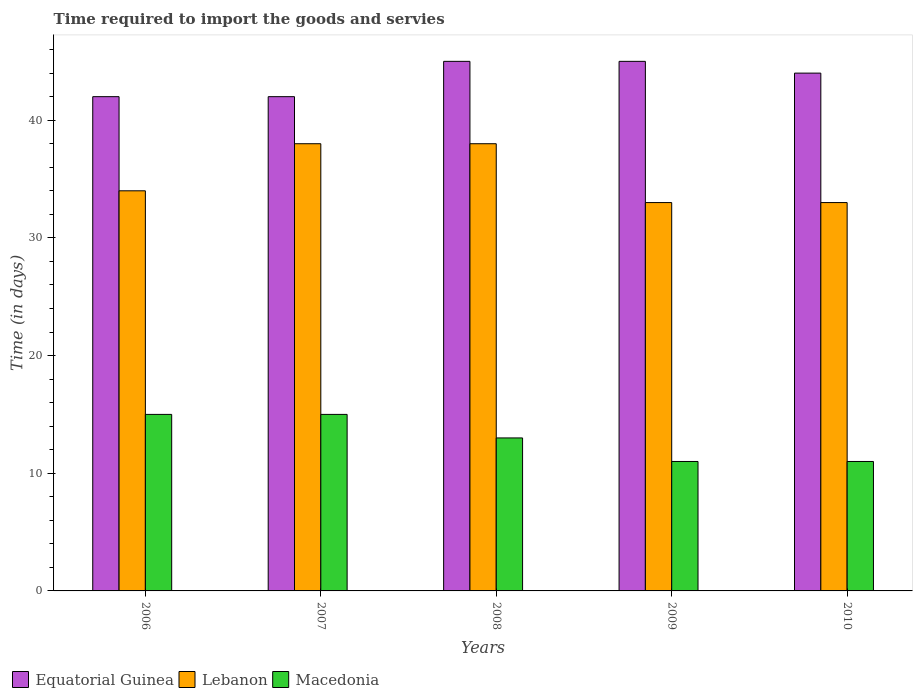How many different coloured bars are there?
Keep it short and to the point. 3. How many bars are there on the 4th tick from the left?
Offer a very short reply. 3. How many bars are there on the 5th tick from the right?
Provide a short and direct response. 3. What is the label of the 5th group of bars from the left?
Your response must be concise. 2010. What is the number of days required to import the goods and services in Lebanon in 2009?
Your answer should be very brief. 33. Across all years, what is the maximum number of days required to import the goods and services in Macedonia?
Provide a short and direct response. 15. Across all years, what is the minimum number of days required to import the goods and services in Equatorial Guinea?
Give a very brief answer. 42. In which year was the number of days required to import the goods and services in Macedonia maximum?
Provide a succinct answer. 2006. In which year was the number of days required to import the goods and services in Macedonia minimum?
Provide a short and direct response. 2009. What is the total number of days required to import the goods and services in Macedonia in the graph?
Offer a very short reply. 65. What is the difference between the number of days required to import the goods and services in Lebanon in 2007 and that in 2009?
Your response must be concise. 5. What is the difference between the number of days required to import the goods and services in Macedonia in 2010 and the number of days required to import the goods and services in Lebanon in 2006?
Ensure brevity in your answer.  -23. In the year 2009, what is the difference between the number of days required to import the goods and services in Lebanon and number of days required to import the goods and services in Macedonia?
Make the answer very short. 22. In how many years, is the number of days required to import the goods and services in Equatorial Guinea greater than 20 days?
Your response must be concise. 5. What is the ratio of the number of days required to import the goods and services in Equatorial Guinea in 2007 to that in 2008?
Give a very brief answer. 0.93. What is the difference between the highest and the second highest number of days required to import the goods and services in Equatorial Guinea?
Your answer should be compact. 0. What is the difference between the highest and the lowest number of days required to import the goods and services in Equatorial Guinea?
Your answer should be very brief. 3. In how many years, is the number of days required to import the goods and services in Macedonia greater than the average number of days required to import the goods and services in Macedonia taken over all years?
Provide a succinct answer. 2. What does the 3rd bar from the left in 2010 represents?
Offer a very short reply. Macedonia. What does the 1st bar from the right in 2009 represents?
Offer a very short reply. Macedonia. Is it the case that in every year, the sum of the number of days required to import the goods and services in Lebanon and number of days required to import the goods and services in Equatorial Guinea is greater than the number of days required to import the goods and services in Macedonia?
Your answer should be compact. Yes. Are all the bars in the graph horizontal?
Give a very brief answer. No. How many years are there in the graph?
Offer a very short reply. 5. Are the values on the major ticks of Y-axis written in scientific E-notation?
Offer a terse response. No. Does the graph contain grids?
Give a very brief answer. No. How many legend labels are there?
Provide a succinct answer. 3. How are the legend labels stacked?
Your answer should be very brief. Horizontal. What is the title of the graph?
Give a very brief answer. Time required to import the goods and servies. Does "Qatar" appear as one of the legend labels in the graph?
Offer a very short reply. No. What is the label or title of the X-axis?
Your answer should be very brief. Years. What is the label or title of the Y-axis?
Ensure brevity in your answer.  Time (in days). What is the Time (in days) in Macedonia in 2006?
Your answer should be compact. 15. What is the Time (in days) in Lebanon in 2007?
Offer a terse response. 38. What is the Time (in days) in Macedonia in 2007?
Provide a short and direct response. 15. What is the Time (in days) in Equatorial Guinea in 2008?
Ensure brevity in your answer.  45. What is the Time (in days) of Lebanon in 2008?
Provide a succinct answer. 38. What is the Time (in days) in Lebanon in 2009?
Make the answer very short. 33. What is the Time (in days) in Macedonia in 2009?
Give a very brief answer. 11. What is the Time (in days) in Lebanon in 2010?
Give a very brief answer. 33. What is the Time (in days) in Macedonia in 2010?
Offer a very short reply. 11. Across all years, what is the maximum Time (in days) in Lebanon?
Provide a succinct answer. 38. Across all years, what is the maximum Time (in days) of Macedonia?
Ensure brevity in your answer.  15. Across all years, what is the minimum Time (in days) in Macedonia?
Your answer should be very brief. 11. What is the total Time (in days) in Equatorial Guinea in the graph?
Your response must be concise. 218. What is the total Time (in days) of Lebanon in the graph?
Offer a very short reply. 176. What is the difference between the Time (in days) of Lebanon in 2006 and that in 2007?
Offer a very short reply. -4. What is the difference between the Time (in days) in Macedonia in 2006 and that in 2007?
Make the answer very short. 0. What is the difference between the Time (in days) in Equatorial Guinea in 2006 and that in 2008?
Offer a very short reply. -3. What is the difference between the Time (in days) in Lebanon in 2006 and that in 2008?
Offer a very short reply. -4. What is the difference between the Time (in days) of Macedonia in 2006 and that in 2008?
Offer a very short reply. 2. What is the difference between the Time (in days) of Equatorial Guinea in 2006 and that in 2009?
Make the answer very short. -3. What is the difference between the Time (in days) of Macedonia in 2006 and that in 2009?
Offer a very short reply. 4. What is the difference between the Time (in days) in Equatorial Guinea in 2006 and that in 2010?
Provide a short and direct response. -2. What is the difference between the Time (in days) in Lebanon in 2007 and that in 2008?
Offer a terse response. 0. What is the difference between the Time (in days) in Equatorial Guinea in 2007 and that in 2009?
Your answer should be very brief. -3. What is the difference between the Time (in days) in Macedonia in 2007 and that in 2009?
Your answer should be very brief. 4. What is the difference between the Time (in days) in Equatorial Guinea in 2007 and that in 2010?
Make the answer very short. -2. What is the difference between the Time (in days) in Lebanon in 2007 and that in 2010?
Your response must be concise. 5. What is the difference between the Time (in days) in Macedonia in 2007 and that in 2010?
Give a very brief answer. 4. What is the difference between the Time (in days) in Equatorial Guinea in 2008 and that in 2009?
Keep it short and to the point. 0. What is the difference between the Time (in days) of Macedonia in 2008 and that in 2009?
Offer a very short reply. 2. What is the difference between the Time (in days) of Lebanon in 2008 and that in 2010?
Make the answer very short. 5. What is the difference between the Time (in days) of Macedonia in 2008 and that in 2010?
Offer a very short reply. 2. What is the difference between the Time (in days) of Equatorial Guinea in 2009 and that in 2010?
Offer a very short reply. 1. What is the difference between the Time (in days) of Lebanon in 2009 and that in 2010?
Provide a succinct answer. 0. What is the difference between the Time (in days) of Macedonia in 2009 and that in 2010?
Give a very brief answer. 0. What is the difference between the Time (in days) in Equatorial Guinea in 2006 and the Time (in days) in Lebanon in 2007?
Ensure brevity in your answer.  4. What is the difference between the Time (in days) in Lebanon in 2006 and the Time (in days) in Macedonia in 2007?
Your answer should be compact. 19. What is the difference between the Time (in days) of Lebanon in 2006 and the Time (in days) of Macedonia in 2008?
Your answer should be compact. 21. What is the difference between the Time (in days) in Equatorial Guinea in 2006 and the Time (in days) in Lebanon in 2009?
Provide a short and direct response. 9. What is the difference between the Time (in days) of Equatorial Guinea in 2007 and the Time (in days) of Macedonia in 2008?
Your answer should be compact. 29. What is the difference between the Time (in days) of Lebanon in 2007 and the Time (in days) of Macedonia in 2008?
Provide a succinct answer. 25. What is the difference between the Time (in days) in Equatorial Guinea in 2007 and the Time (in days) in Lebanon in 2009?
Provide a short and direct response. 9. What is the difference between the Time (in days) of Equatorial Guinea in 2007 and the Time (in days) of Macedonia in 2009?
Give a very brief answer. 31. What is the difference between the Time (in days) in Equatorial Guinea in 2007 and the Time (in days) in Lebanon in 2010?
Your answer should be very brief. 9. What is the difference between the Time (in days) of Equatorial Guinea in 2008 and the Time (in days) of Lebanon in 2009?
Make the answer very short. 12. What is the difference between the Time (in days) of Equatorial Guinea in 2008 and the Time (in days) of Macedonia in 2009?
Keep it short and to the point. 34. What is the difference between the Time (in days) in Lebanon in 2008 and the Time (in days) in Macedonia in 2009?
Ensure brevity in your answer.  27. What is the difference between the Time (in days) in Equatorial Guinea in 2008 and the Time (in days) in Lebanon in 2010?
Make the answer very short. 12. What is the difference between the Time (in days) in Equatorial Guinea in 2008 and the Time (in days) in Macedonia in 2010?
Your answer should be compact. 34. What is the difference between the Time (in days) of Lebanon in 2008 and the Time (in days) of Macedonia in 2010?
Keep it short and to the point. 27. What is the difference between the Time (in days) of Equatorial Guinea in 2009 and the Time (in days) of Lebanon in 2010?
Your answer should be very brief. 12. What is the difference between the Time (in days) of Equatorial Guinea in 2009 and the Time (in days) of Macedonia in 2010?
Provide a succinct answer. 34. What is the difference between the Time (in days) in Lebanon in 2009 and the Time (in days) in Macedonia in 2010?
Give a very brief answer. 22. What is the average Time (in days) of Equatorial Guinea per year?
Your answer should be very brief. 43.6. What is the average Time (in days) in Lebanon per year?
Give a very brief answer. 35.2. What is the average Time (in days) in Macedonia per year?
Offer a terse response. 13. In the year 2006, what is the difference between the Time (in days) of Equatorial Guinea and Time (in days) of Lebanon?
Provide a succinct answer. 8. In the year 2007, what is the difference between the Time (in days) in Lebanon and Time (in days) in Macedonia?
Your answer should be compact. 23. In the year 2009, what is the difference between the Time (in days) in Equatorial Guinea and Time (in days) in Macedonia?
Provide a short and direct response. 34. In the year 2009, what is the difference between the Time (in days) in Lebanon and Time (in days) in Macedonia?
Give a very brief answer. 22. What is the ratio of the Time (in days) in Equatorial Guinea in 2006 to that in 2007?
Your response must be concise. 1. What is the ratio of the Time (in days) of Lebanon in 2006 to that in 2007?
Your response must be concise. 0.89. What is the ratio of the Time (in days) in Lebanon in 2006 to that in 2008?
Your answer should be very brief. 0.89. What is the ratio of the Time (in days) of Macedonia in 2006 to that in 2008?
Your answer should be very brief. 1.15. What is the ratio of the Time (in days) in Lebanon in 2006 to that in 2009?
Give a very brief answer. 1.03. What is the ratio of the Time (in days) of Macedonia in 2006 to that in 2009?
Keep it short and to the point. 1.36. What is the ratio of the Time (in days) of Equatorial Guinea in 2006 to that in 2010?
Provide a short and direct response. 0.95. What is the ratio of the Time (in days) in Lebanon in 2006 to that in 2010?
Offer a very short reply. 1.03. What is the ratio of the Time (in days) in Macedonia in 2006 to that in 2010?
Your answer should be very brief. 1.36. What is the ratio of the Time (in days) of Lebanon in 2007 to that in 2008?
Provide a short and direct response. 1. What is the ratio of the Time (in days) of Macedonia in 2007 to that in 2008?
Provide a short and direct response. 1.15. What is the ratio of the Time (in days) of Lebanon in 2007 to that in 2009?
Keep it short and to the point. 1.15. What is the ratio of the Time (in days) in Macedonia in 2007 to that in 2009?
Your answer should be very brief. 1.36. What is the ratio of the Time (in days) in Equatorial Guinea in 2007 to that in 2010?
Keep it short and to the point. 0.95. What is the ratio of the Time (in days) of Lebanon in 2007 to that in 2010?
Provide a succinct answer. 1.15. What is the ratio of the Time (in days) in Macedonia in 2007 to that in 2010?
Your response must be concise. 1.36. What is the ratio of the Time (in days) in Lebanon in 2008 to that in 2009?
Make the answer very short. 1.15. What is the ratio of the Time (in days) in Macedonia in 2008 to that in 2009?
Your response must be concise. 1.18. What is the ratio of the Time (in days) in Equatorial Guinea in 2008 to that in 2010?
Provide a succinct answer. 1.02. What is the ratio of the Time (in days) in Lebanon in 2008 to that in 2010?
Provide a succinct answer. 1.15. What is the ratio of the Time (in days) of Macedonia in 2008 to that in 2010?
Provide a short and direct response. 1.18. What is the ratio of the Time (in days) in Equatorial Guinea in 2009 to that in 2010?
Ensure brevity in your answer.  1.02. What is the ratio of the Time (in days) of Lebanon in 2009 to that in 2010?
Provide a succinct answer. 1. What is the difference between the highest and the second highest Time (in days) of Equatorial Guinea?
Your answer should be very brief. 0. What is the difference between the highest and the second highest Time (in days) in Lebanon?
Offer a terse response. 0. What is the difference between the highest and the second highest Time (in days) in Macedonia?
Keep it short and to the point. 0. What is the difference between the highest and the lowest Time (in days) in Lebanon?
Offer a terse response. 5. 